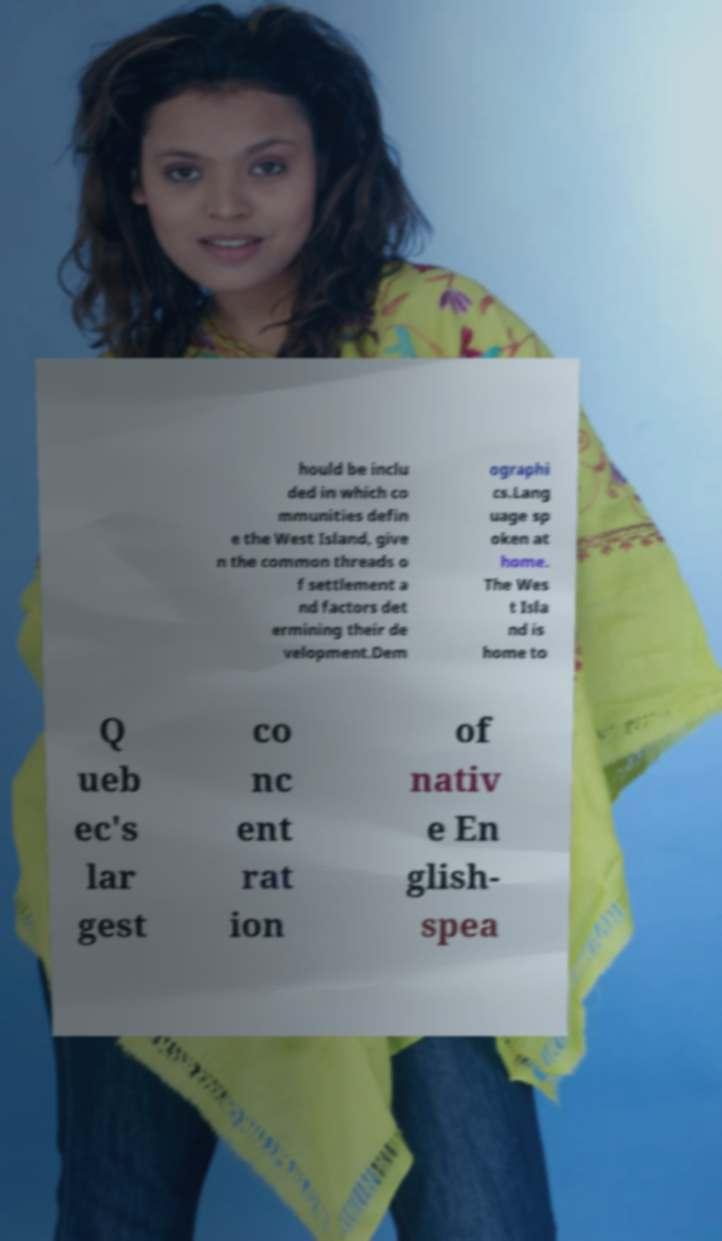Please identify and transcribe the text found in this image. hould be inclu ded in which co mmunities defin e the West Island, give n the common threads o f settlement a nd factors det ermining their de velopment.Dem ographi cs.Lang uage sp oken at home. The Wes t Isla nd is home to Q ueb ec's lar gest co nc ent rat ion of nativ e En glish- spea 